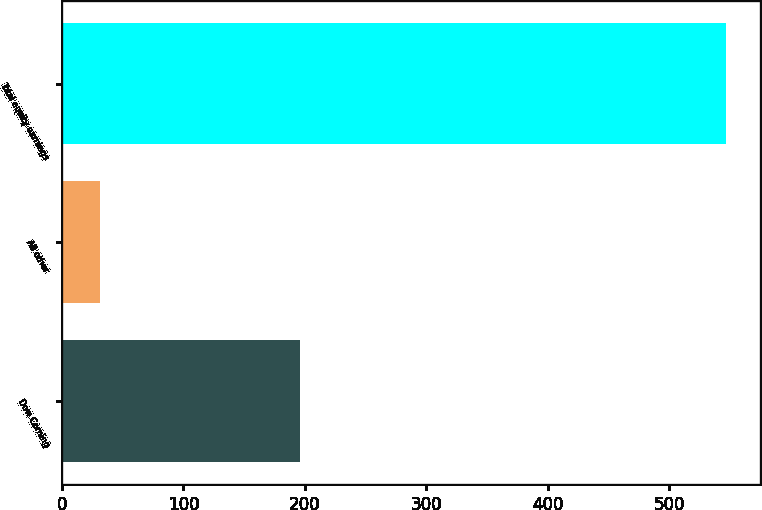Convert chart to OTSL. <chart><loc_0><loc_0><loc_500><loc_500><bar_chart><fcel>Dow Corning<fcel>All other<fcel>Total equity earnings<nl><fcel>196<fcel>31<fcel>547<nl></chart> 